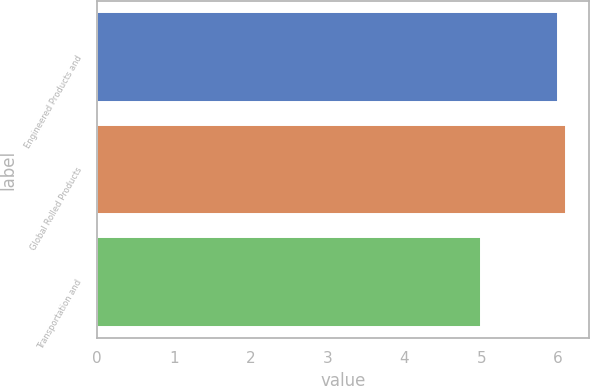<chart> <loc_0><loc_0><loc_500><loc_500><bar_chart><fcel>Engineered Products and<fcel>Global Rolled Products<fcel>Transportation and<nl><fcel>6<fcel>6.1<fcel>5<nl></chart> 